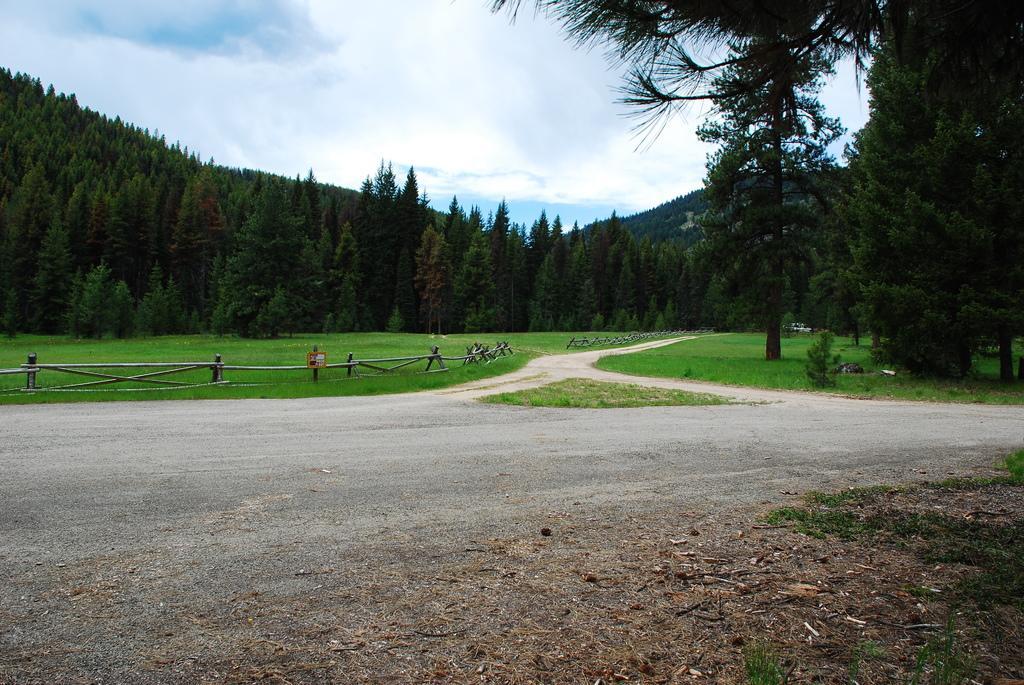Please provide a concise description of this image. In this image there is a road, in the background there is wooden railing and grassland, trees, mountain and the sky. 